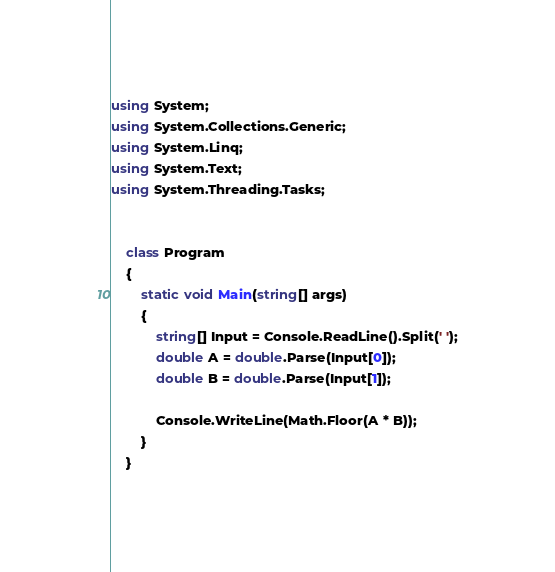<code> <loc_0><loc_0><loc_500><loc_500><_C#_>using System;
using System.Collections.Generic;
using System.Linq;
using System.Text;
using System.Threading.Tasks;


    class Program
    {
        static void Main(string[] args)
        {
            string[] Input = Console.ReadLine().Split(' ');
            double A = double.Parse(Input[0]);
            double B = double.Parse(Input[1]);
            
            Console.WriteLine(Math.Floor(A * B));
        }
    }</code> 